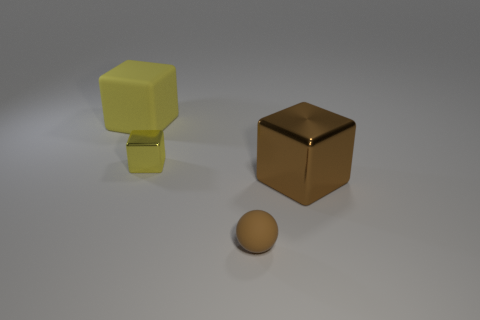Subtract all green blocks. Subtract all blue spheres. How many blocks are left? 3 Add 2 cyan metal cylinders. How many objects exist? 6 Subtract all spheres. How many objects are left? 3 Add 1 small purple matte blocks. How many small purple matte blocks exist? 1 Subtract 0 cyan spheres. How many objects are left? 4 Subtract all big brown balls. Subtract all brown cubes. How many objects are left? 3 Add 2 large brown objects. How many large brown objects are left? 3 